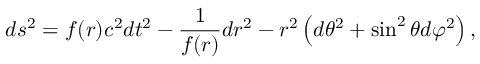<formula> <loc_0><loc_0><loc_500><loc_500>d s ^ { 2 } = f ( r ) c ^ { 2 } d t ^ { 2 } - \frac { 1 } { f ( r ) } d r ^ { 2 } - r ^ { 2 } \left ( d \theta ^ { 2 } + \sin ^ { 2 } \theta d \varphi ^ { 2 } \right ) ,</formula> 